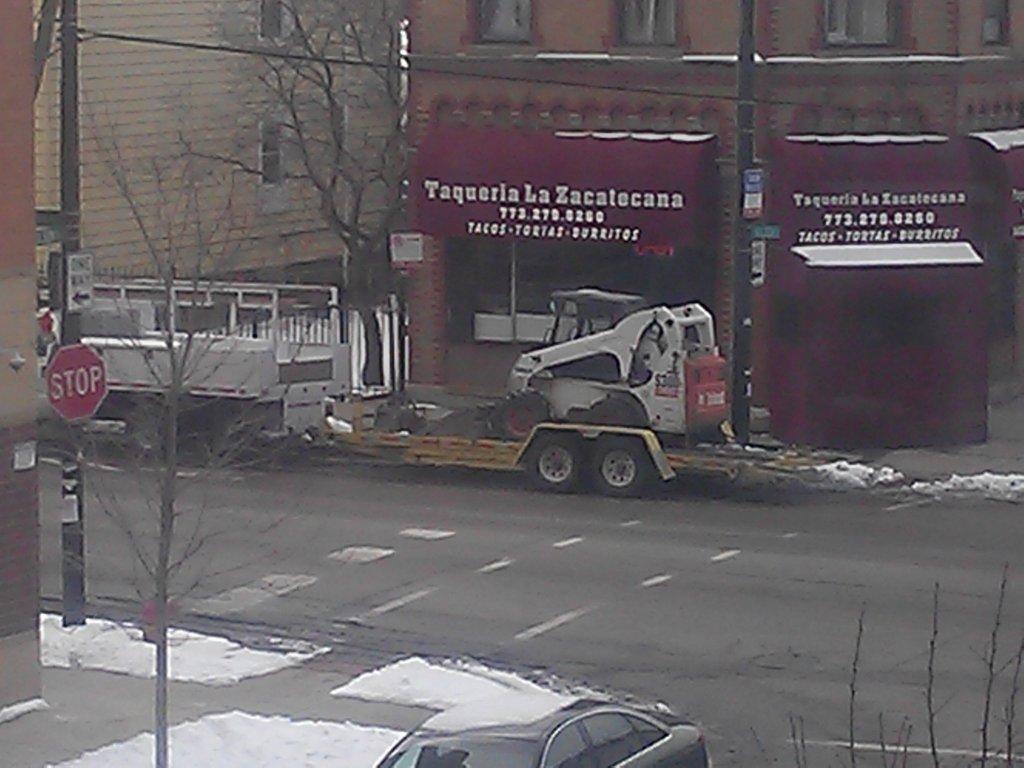Can you describe this image briefly? In this image I can see road, snow, few trees, few vehicles, few poles, few boards and here I can see a red colour sign board. On these boards I can see something is written and I can also see few buildings. 